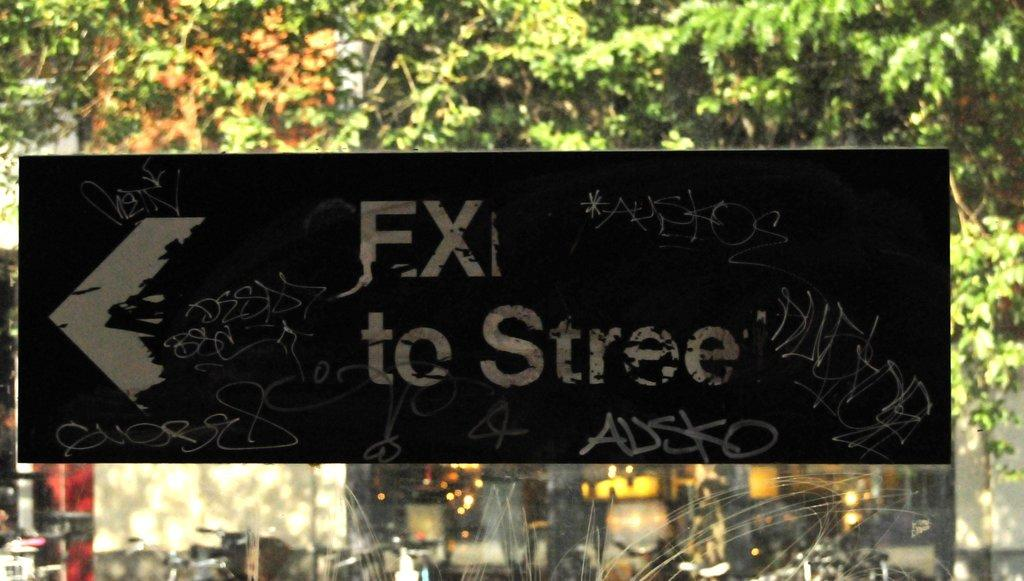What is the main object in the image? There is a blackboard in the image. What is on the blackboard? Something is written on the blackboard. What can be seen in the background of the image? There are trees visible in the image, and there appears to be a building behind the trees. What type of jail is depicted in the image? There is no jail present in the image; it features a blackboard with something written on it, trees, and a building in the background. 